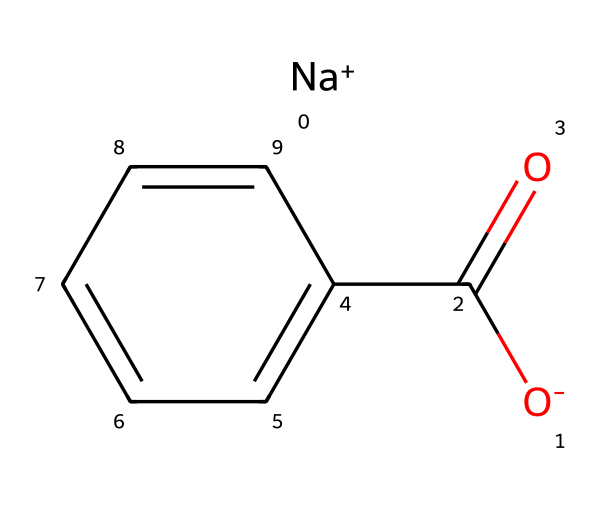What is the molecular formula of sodium benzoate? The molecular structure contains carbon (C), hydrogen (H), oxygen (O), and sodium (Na). Counting the atoms leads to the formula C7H5O2Na, which represents the molecular formula of sodium benzoate.
Answer: C7H5O2Na How many carbon atoms are present in sodium benzoate? In the structure, there are seven carbon atoms present which can be counted directly from the carbon atoms shown in the SMILES representation.
Answer: 7 What type of bond is mainly present between the carbon and the oxygen in the carboxyl group? In the structure, the carbon in the carboxyl group (C(=O)) is attached to oxygen. This indicates a double bond between carbon and oxygen, which is characteristic of carbonyl groups.
Answer: double bond What is the significance of the sodium ion in this molecule? The sodium ion (Na+) is present as a counterion that balances the negative charge from the carboxylate group (O-). This pairing stabilizes the molecule, making it a salt form (sodium benzoate).
Answer: counterion Is sodium benzoate soluble in water? The presence of the ionic sodium ion and the polar carboxylate group suggests that sodium benzoate is soluble in water due to its ability to interact with water molecules.
Answer: yes What type of chemical reaction can sodium benzoate undergo due to its carboxylate group? The carboxylate group in sodium benzoate can undergo esterification reactions, where it reacts with alcohols to form esters, due to the reactivity of the hydroxyl (-OH) part of the carboxyl group.
Answer: esterification 